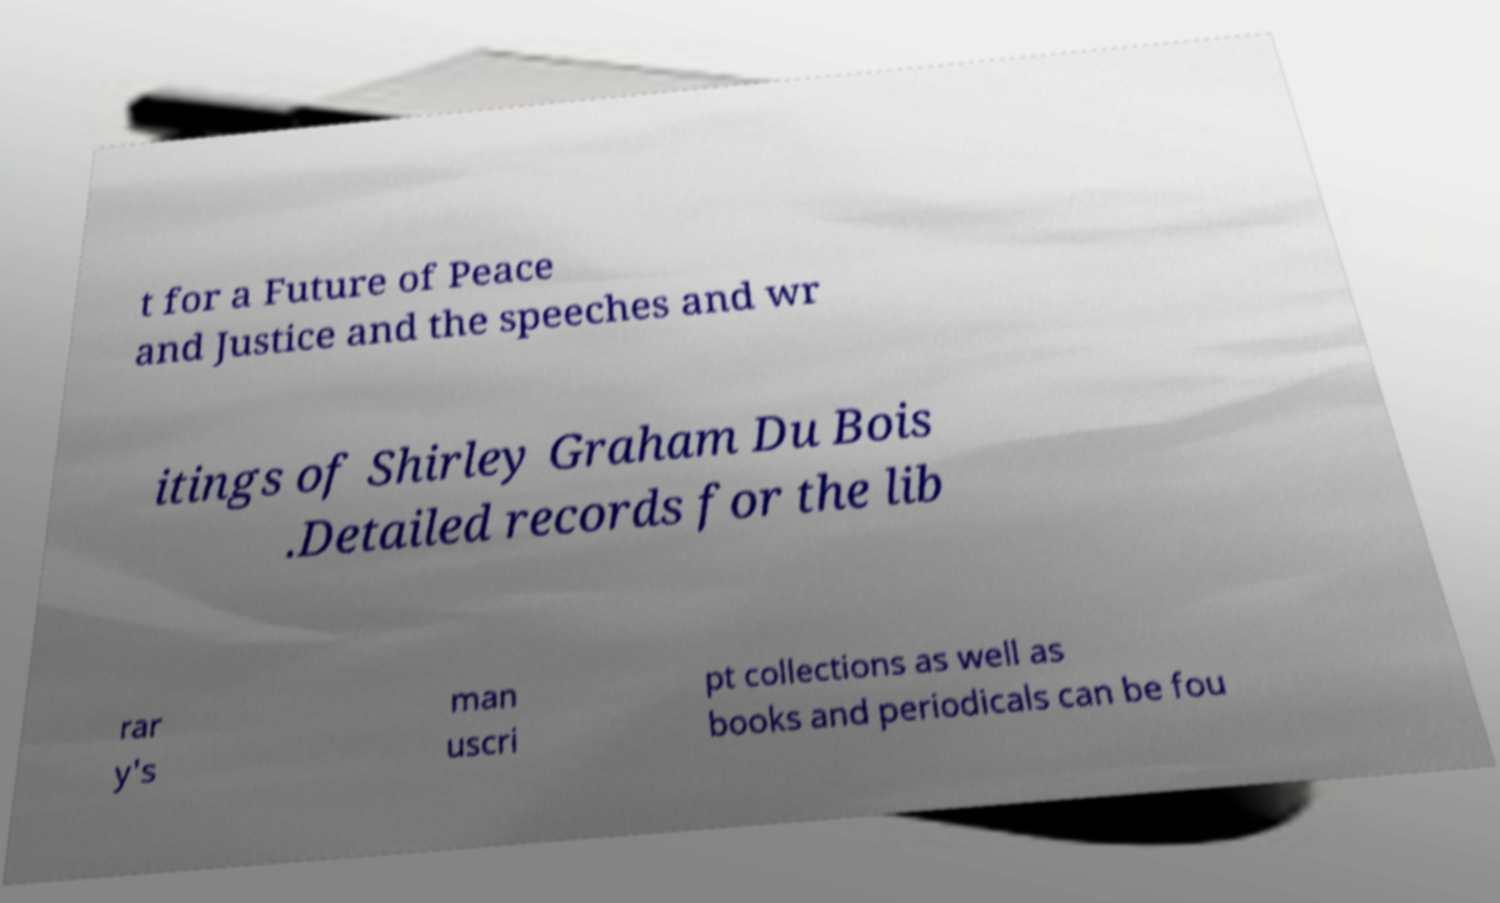Could you assist in decoding the text presented in this image and type it out clearly? t for a Future of Peace and Justice and the speeches and wr itings of Shirley Graham Du Bois .Detailed records for the lib rar y's man uscri pt collections as well as books and periodicals can be fou 